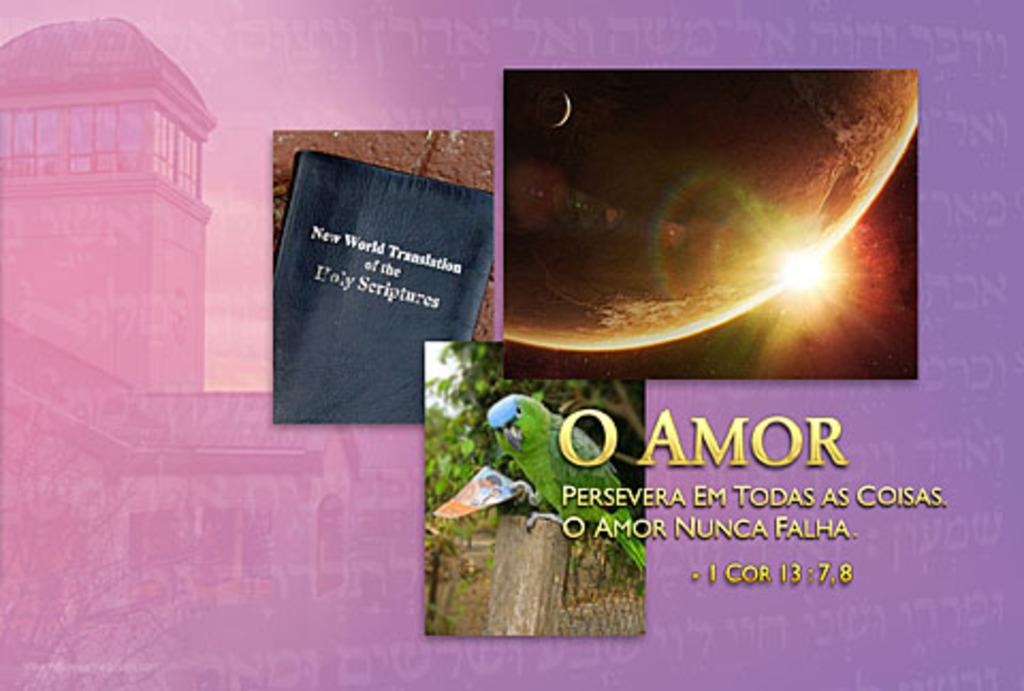Provide a one-sentence caption for the provided image. Three images are presented with a purple background and one image is a book titled New World Translation of the Holy Scriptures. 